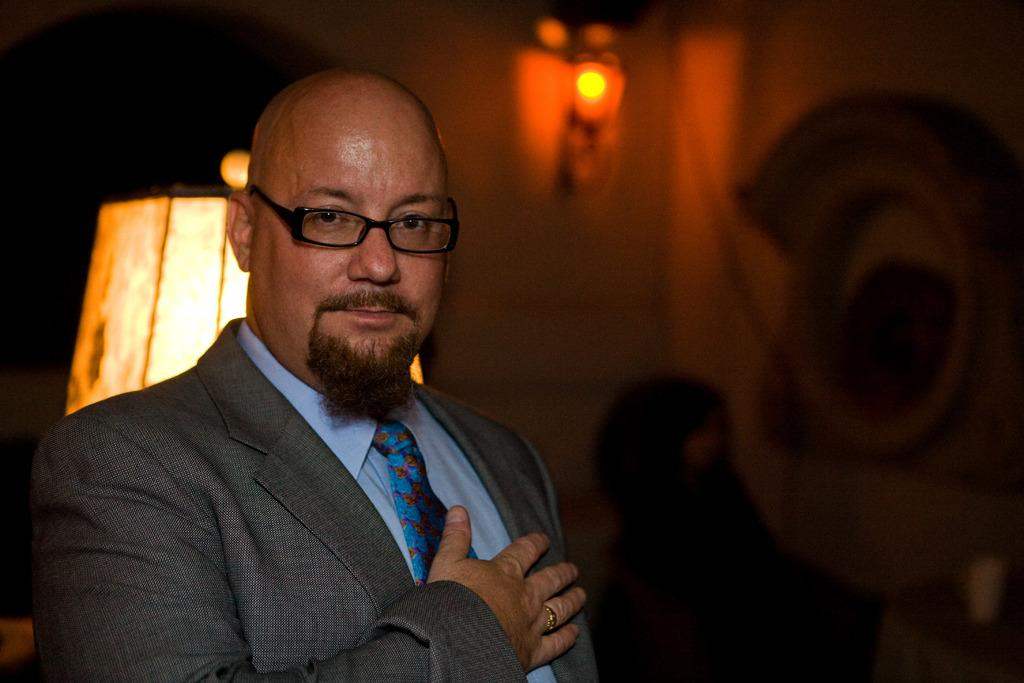Who is the person on the left side of the image? There is a man on the left side of the image. What can be seen in the background of the image? There is a lamp, lights on the wall, and other objects visible in the background of the image. What is the man holding in the image? There is a cup in the image. Can you describe the lighting in the image? There are lights on the wall in the background of the image. What type of spark can be seen coming from the man's finger in the image? There is no spark visible in the image; the man is not sparking or producing any electrical discharge. 